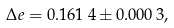<formula> <loc_0><loc_0><loc_500><loc_500>\Delta e = 0 . 1 6 1 \, 4 \pm 0 . 0 0 0 \, 3 ,</formula> 